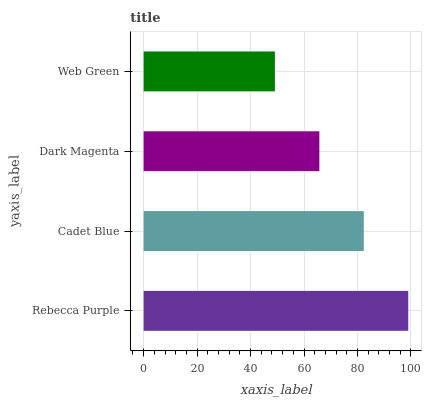Is Web Green the minimum?
Answer yes or no. Yes. Is Rebecca Purple the maximum?
Answer yes or no. Yes. Is Cadet Blue the minimum?
Answer yes or no. No. Is Cadet Blue the maximum?
Answer yes or no. No. Is Rebecca Purple greater than Cadet Blue?
Answer yes or no. Yes. Is Cadet Blue less than Rebecca Purple?
Answer yes or no. Yes. Is Cadet Blue greater than Rebecca Purple?
Answer yes or no. No. Is Rebecca Purple less than Cadet Blue?
Answer yes or no. No. Is Cadet Blue the high median?
Answer yes or no. Yes. Is Dark Magenta the low median?
Answer yes or no. Yes. Is Web Green the high median?
Answer yes or no. No. Is Cadet Blue the low median?
Answer yes or no. No. 